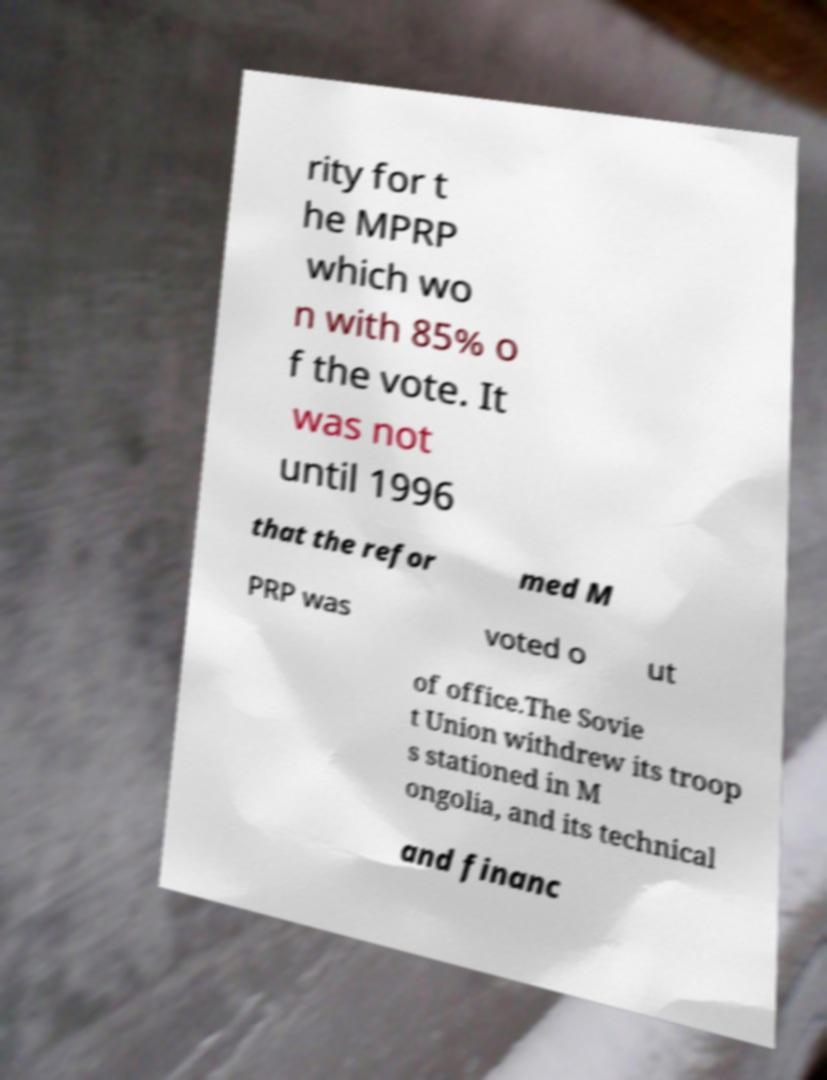For documentation purposes, I need the text within this image transcribed. Could you provide that? rity for t he MPRP which wo n with 85% o f the vote. It was not until 1996 that the refor med M PRP was voted o ut of office.The Sovie t Union withdrew its troop s stationed in M ongolia, and its technical and financ 